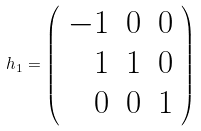Convert formula to latex. <formula><loc_0><loc_0><loc_500><loc_500>h _ { 1 } = \left ( \begin{array} { r r r } - 1 & 0 & 0 \\ 1 & 1 & 0 \\ 0 & 0 & 1 \end{array} \right )</formula> 